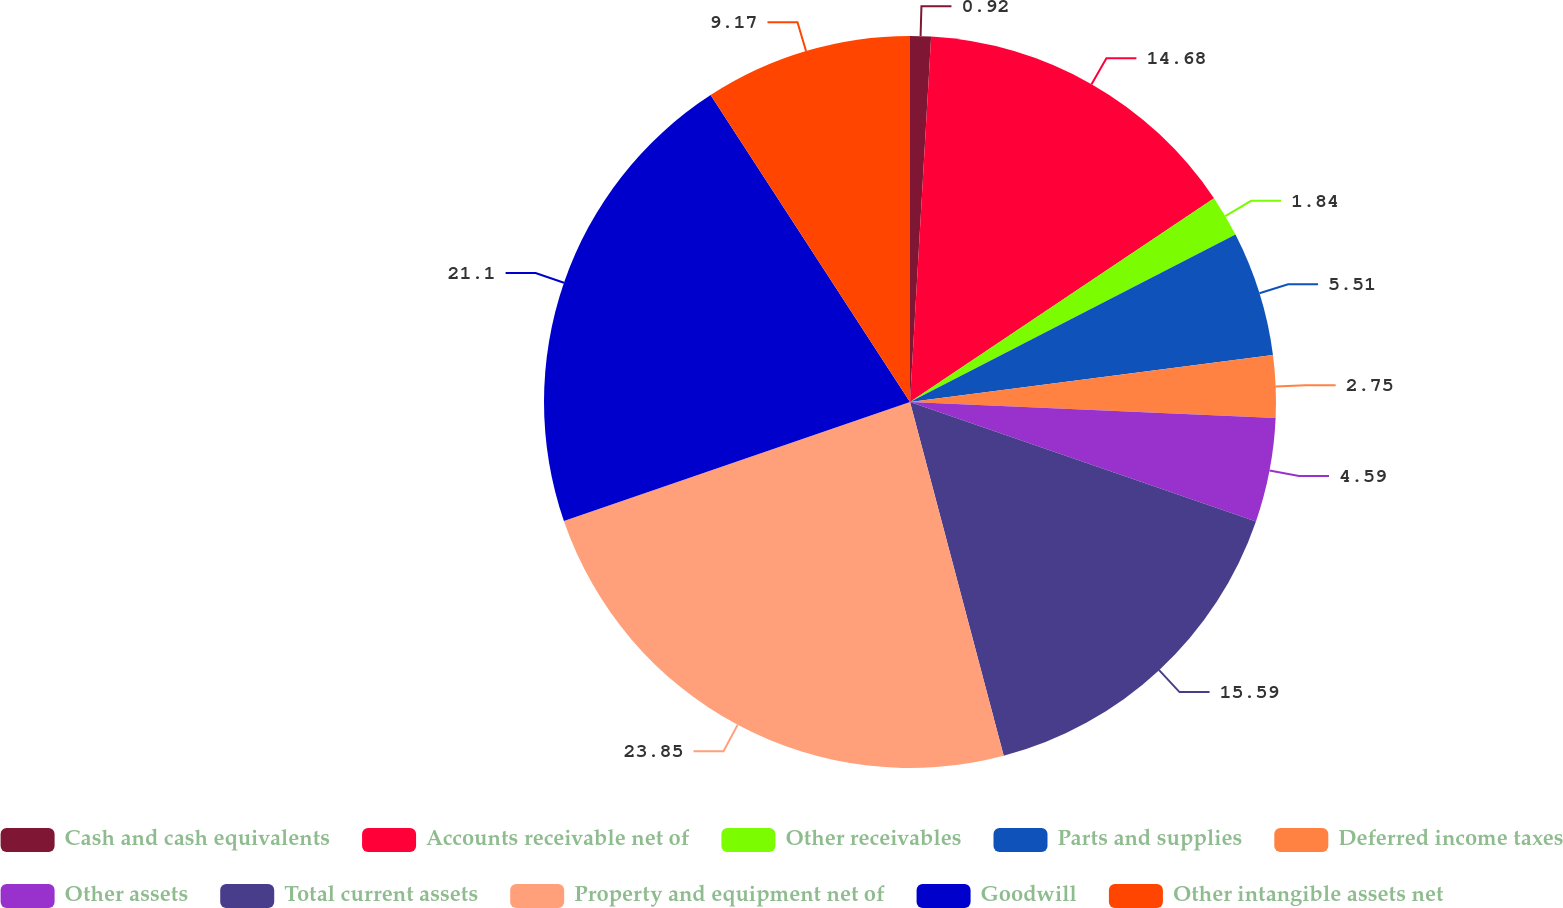Convert chart to OTSL. <chart><loc_0><loc_0><loc_500><loc_500><pie_chart><fcel>Cash and cash equivalents<fcel>Accounts receivable net of<fcel>Other receivables<fcel>Parts and supplies<fcel>Deferred income taxes<fcel>Other assets<fcel>Total current assets<fcel>Property and equipment net of<fcel>Goodwill<fcel>Other intangible assets net<nl><fcel>0.92%<fcel>14.68%<fcel>1.84%<fcel>5.51%<fcel>2.75%<fcel>4.59%<fcel>15.59%<fcel>23.85%<fcel>21.1%<fcel>9.17%<nl></chart> 